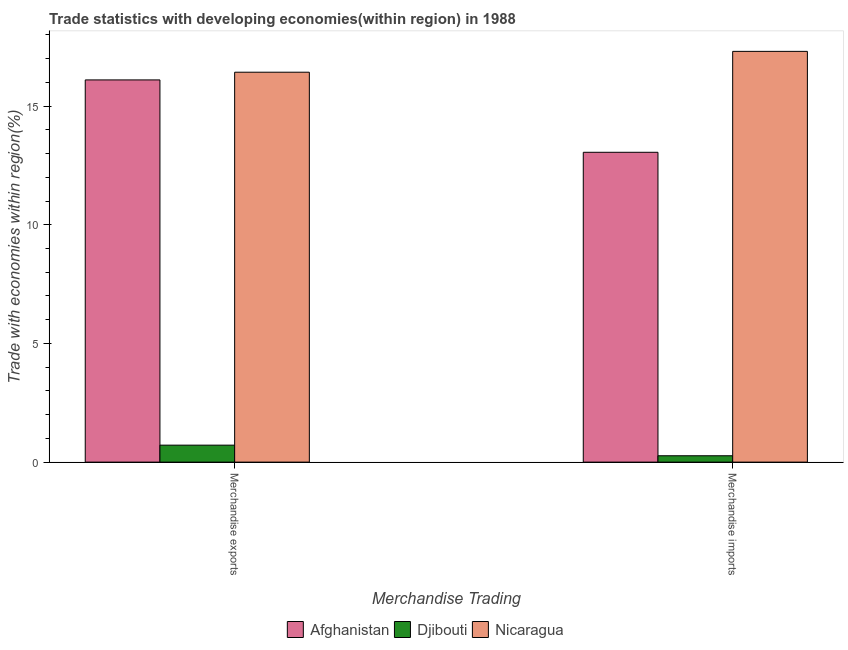How many groups of bars are there?
Provide a short and direct response. 2. Are the number of bars per tick equal to the number of legend labels?
Provide a succinct answer. Yes. What is the merchandise imports in Nicaragua?
Make the answer very short. 17.31. Across all countries, what is the maximum merchandise exports?
Your response must be concise. 16.43. Across all countries, what is the minimum merchandise exports?
Offer a very short reply. 0.72. In which country was the merchandise imports maximum?
Keep it short and to the point. Nicaragua. In which country was the merchandise imports minimum?
Provide a succinct answer. Djibouti. What is the total merchandise imports in the graph?
Offer a terse response. 30.63. What is the difference between the merchandise exports in Nicaragua and that in Djibouti?
Offer a terse response. 15.71. What is the difference between the merchandise imports in Djibouti and the merchandise exports in Nicaragua?
Give a very brief answer. -16.16. What is the average merchandise imports per country?
Offer a very short reply. 10.21. What is the difference between the merchandise exports and merchandise imports in Djibouti?
Offer a terse response. 0.45. In how many countries, is the merchandise exports greater than 7 %?
Offer a terse response. 2. What is the ratio of the merchandise imports in Afghanistan to that in Djibouti?
Offer a very short reply. 48.64. Is the merchandise imports in Nicaragua less than that in Afghanistan?
Make the answer very short. No. What does the 3rd bar from the left in Merchandise imports represents?
Provide a short and direct response. Nicaragua. What does the 2nd bar from the right in Merchandise imports represents?
Offer a very short reply. Djibouti. How many countries are there in the graph?
Make the answer very short. 3. What is the difference between two consecutive major ticks on the Y-axis?
Offer a very short reply. 5. Does the graph contain any zero values?
Provide a short and direct response. No. Does the graph contain grids?
Offer a terse response. No. How many legend labels are there?
Give a very brief answer. 3. What is the title of the graph?
Offer a very short reply. Trade statistics with developing economies(within region) in 1988. What is the label or title of the X-axis?
Make the answer very short. Merchandise Trading. What is the label or title of the Y-axis?
Your answer should be compact. Trade with economies within region(%). What is the Trade with economies within region(%) of Afghanistan in Merchandise exports?
Give a very brief answer. 16.1. What is the Trade with economies within region(%) of Djibouti in Merchandise exports?
Keep it short and to the point. 0.72. What is the Trade with economies within region(%) in Nicaragua in Merchandise exports?
Offer a very short reply. 16.43. What is the Trade with economies within region(%) of Afghanistan in Merchandise imports?
Give a very brief answer. 13.05. What is the Trade with economies within region(%) in Djibouti in Merchandise imports?
Your response must be concise. 0.27. What is the Trade with economies within region(%) of Nicaragua in Merchandise imports?
Your answer should be compact. 17.31. Across all Merchandise Trading, what is the maximum Trade with economies within region(%) in Afghanistan?
Provide a short and direct response. 16.1. Across all Merchandise Trading, what is the maximum Trade with economies within region(%) in Djibouti?
Ensure brevity in your answer.  0.72. Across all Merchandise Trading, what is the maximum Trade with economies within region(%) in Nicaragua?
Provide a short and direct response. 17.31. Across all Merchandise Trading, what is the minimum Trade with economies within region(%) of Afghanistan?
Your answer should be very brief. 13.05. Across all Merchandise Trading, what is the minimum Trade with economies within region(%) of Djibouti?
Give a very brief answer. 0.27. Across all Merchandise Trading, what is the minimum Trade with economies within region(%) in Nicaragua?
Your answer should be compact. 16.43. What is the total Trade with economies within region(%) in Afghanistan in the graph?
Offer a terse response. 29.16. What is the total Trade with economies within region(%) of Djibouti in the graph?
Provide a succinct answer. 0.98. What is the total Trade with economies within region(%) in Nicaragua in the graph?
Provide a short and direct response. 33.74. What is the difference between the Trade with economies within region(%) in Afghanistan in Merchandise exports and that in Merchandise imports?
Make the answer very short. 3.05. What is the difference between the Trade with economies within region(%) of Djibouti in Merchandise exports and that in Merchandise imports?
Your response must be concise. 0.45. What is the difference between the Trade with economies within region(%) in Nicaragua in Merchandise exports and that in Merchandise imports?
Your answer should be very brief. -0.88. What is the difference between the Trade with economies within region(%) of Afghanistan in Merchandise exports and the Trade with economies within region(%) of Djibouti in Merchandise imports?
Your answer should be very brief. 15.84. What is the difference between the Trade with economies within region(%) of Afghanistan in Merchandise exports and the Trade with economies within region(%) of Nicaragua in Merchandise imports?
Your answer should be very brief. -1.2. What is the difference between the Trade with economies within region(%) in Djibouti in Merchandise exports and the Trade with economies within region(%) in Nicaragua in Merchandise imports?
Your response must be concise. -16.59. What is the average Trade with economies within region(%) in Afghanistan per Merchandise Trading?
Offer a terse response. 14.58. What is the average Trade with economies within region(%) in Djibouti per Merchandise Trading?
Ensure brevity in your answer.  0.49. What is the average Trade with economies within region(%) of Nicaragua per Merchandise Trading?
Provide a succinct answer. 16.87. What is the difference between the Trade with economies within region(%) of Afghanistan and Trade with economies within region(%) of Djibouti in Merchandise exports?
Offer a very short reply. 15.39. What is the difference between the Trade with economies within region(%) in Afghanistan and Trade with economies within region(%) in Nicaragua in Merchandise exports?
Ensure brevity in your answer.  -0.32. What is the difference between the Trade with economies within region(%) of Djibouti and Trade with economies within region(%) of Nicaragua in Merchandise exports?
Offer a very short reply. -15.71. What is the difference between the Trade with economies within region(%) in Afghanistan and Trade with economies within region(%) in Djibouti in Merchandise imports?
Provide a succinct answer. 12.79. What is the difference between the Trade with economies within region(%) in Afghanistan and Trade with economies within region(%) in Nicaragua in Merchandise imports?
Offer a terse response. -4.25. What is the difference between the Trade with economies within region(%) of Djibouti and Trade with economies within region(%) of Nicaragua in Merchandise imports?
Your response must be concise. -17.04. What is the ratio of the Trade with economies within region(%) in Afghanistan in Merchandise exports to that in Merchandise imports?
Keep it short and to the point. 1.23. What is the ratio of the Trade with economies within region(%) in Djibouti in Merchandise exports to that in Merchandise imports?
Make the answer very short. 2.66. What is the ratio of the Trade with economies within region(%) of Nicaragua in Merchandise exports to that in Merchandise imports?
Provide a succinct answer. 0.95. What is the difference between the highest and the second highest Trade with economies within region(%) in Afghanistan?
Provide a short and direct response. 3.05. What is the difference between the highest and the second highest Trade with economies within region(%) of Djibouti?
Provide a succinct answer. 0.45. What is the difference between the highest and the second highest Trade with economies within region(%) in Nicaragua?
Offer a terse response. 0.88. What is the difference between the highest and the lowest Trade with economies within region(%) of Afghanistan?
Offer a terse response. 3.05. What is the difference between the highest and the lowest Trade with economies within region(%) of Djibouti?
Offer a very short reply. 0.45. What is the difference between the highest and the lowest Trade with economies within region(%) in Nicaragua?
Make the answer very short. 0.88. 